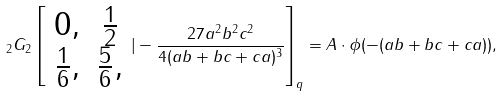<formula> <loc_0><loc_0><loc_500><loc_500>_ { 2 } G _ { 2 } \left [ \begin{array} { c c } 0 , & \frac { 1 } { 2 } \\ \frac { 1 } { 6 } , & \frac { 5 } { 6 } , \end{array} | - \frac { 2 7 a ^ { 2 } b ^ { 2 } c ^ { 2 } } { 4 ( a b + b c + c a ) ^ { 3 } } \right ] _ { q } = A \cdot \phi ( - ( a b + b c + c a ) ) ,</formula> 